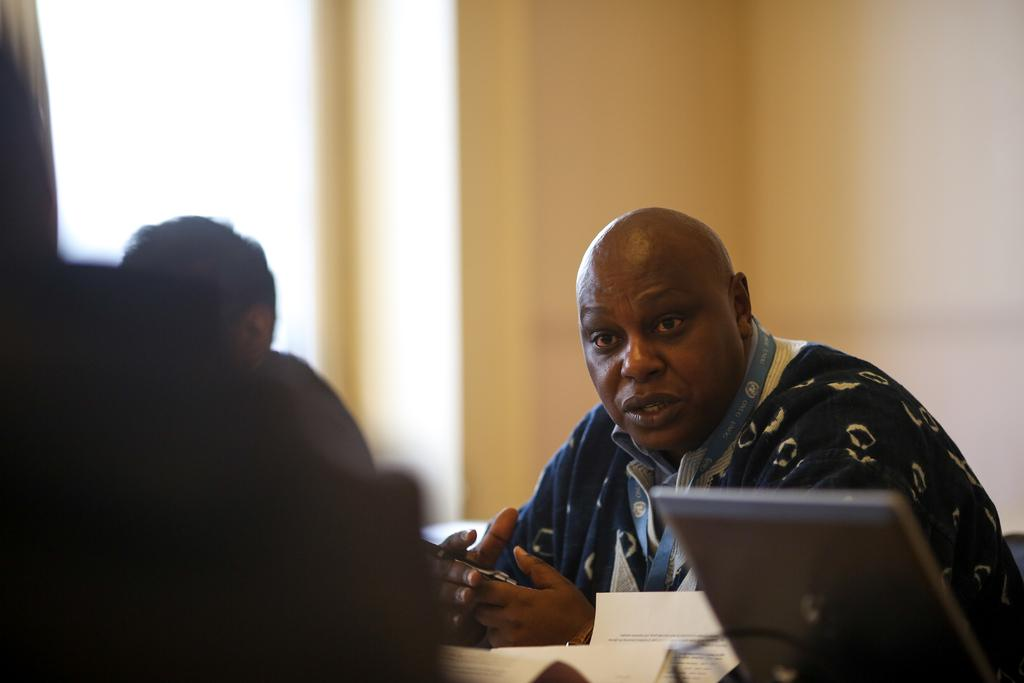How many people are in the image? There are two persons in the image. What objects can be seen in the image besides the people? There are papers and a laptop visible in the image. What can be seen in the background of the image? There is a wall and a window in the background of the image. How is the lighting on the left side of the image? The left side of the image is dark. What type of jelly is being used to hold the laptop in the image? There is no jelly present in the image, and the laptop is not being held by any jelly. What is the experience of the persons in the image? The provided facts do not give any information about the experience or emotions of the persons in the image. --- Facts: 1. There is a car in the image. 2. The car is red. 3. There are trees in the background of the image. 4. The sky is visible in the image. 5. The car has four wheels. Absurd Topics: parrot, hat, ocean Conversation: What is the main subject of the image? The main subject of the image is a car. What color is the car? The car is red. What can be seen in the background of the image? There are trees and the sky visible in the image. How many wheels does the car have? The car has four wheels. Reasoning: Let's think step by step in order to produce the conversation. We start by identifying the main subject of the image, which is the car. Then, we describe the color of the car, which is red. Next, we mention the background of the image, noting the presence of trees and the sky. Finally, we address the car's features, specifically the number of wheels, which is four. Absurd Question/Answer: Can you tell me how many parrots are sitting on the car in the image? There are no parrots present in the image; it only features a red car with four wheels. Is the car wearing a hat in the image? There is no hat present in the image, and the car is not wearing any clothing or accessories. 